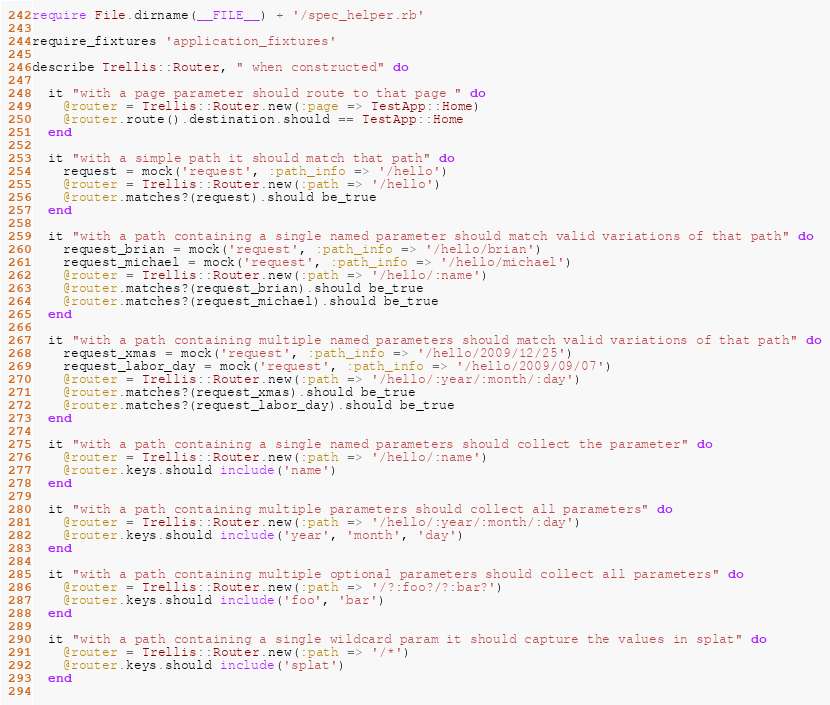<code> <loc_0><loc_0><loc_500><loc_500><_Ruby_>require File.dirname(__FILE__) + '/spec_helper.rb'

require_fixtures 'application_fixtures'

describe Trellis::Router, " when constructed" do

  it "with a page parameter should route to that page " do
    @router = Trellis::Router.new(:page => TestApp::Home)
    @router.route().destination.should == TestApp::Home
  end

  it "with a simple path it should match that path" do
    request = mock('request', :path_info => '/hello')
    @router = Trellis::Router.new(:path => '/hello')
    @router.matches?(request).should be_true
  end

  it "with a path containing a single named parameter should match valid variations of that path" do
    request_brian = mock('request', :path_info => '/hello/brian')
    request_michael = mock('request', :path_info => '/hello/michael')
    @router = Trellis::Router.new(:path => '/hello/:name')
    @router.matches?(request_brian).should be_true
    @router.matches?(request_michael).should be_true
  end

  it "with a path containing multiple named parameters should match valid variations of that path" do
    request_xmas = mock('request', :path_info => '/hello/2009/12/25')
    request_labor_day = mock('request', :path_info => '/hello/2009/09/07')
    @router = Trellis::Router.new(:path => '/hello/:year/:month/:day')
    @router.matches?(request_xmas).should be_true
    @router.matches?(request_labor_day).should be_true
  end

  it "with a path containing a single named parameters should collect the parameter" do
    @router = Trellis::Router.new(:path => '/hello/:name')
    @router.keys.should include('name')
  end

  it "with a path containing multiple parameters should collect all parameters" do
    @router = Trellis::Router.new(:path => '/hello/:year/:month/:day')
    @router.keys.should include('year', 'month', 'day')
  end

  it "with a path containing multiple optional parameters should collect all parameters" do
    @router = Trellis::Router.new(:path => '/?:foo?/?:bar?')
    @router.keys.should include('foo', 'bar')
  end

  it "with a path containing a single wildcard param it should capture the values in splat" do
    @router = Trellis::Router.new(:path => '/*')
    @router.keys.should include('splat')
  end
  </code> 